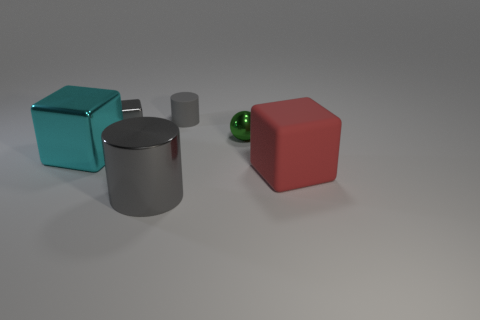What can you infer about the texture of these objects? The objects seem to have a smooth texture overall, though the light's interaction with their surfaces suggests the silver cylinder and the teal cube have a potentially more reflective finish compared to the other objects. How is the lighting arranged in this image? There appears to be a primary light source from above, casting soft shadows beneath the objects, which also contributes to the highlights seen on the reflective surfaces. 